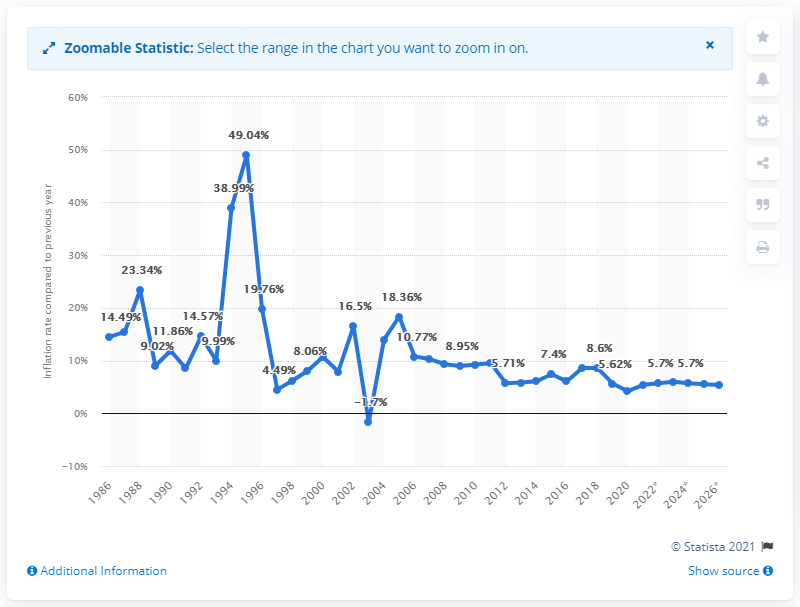Draw attention to some important aspects in this diagram. In 2020, the inflation rate in Madagascar was 4.19%. 